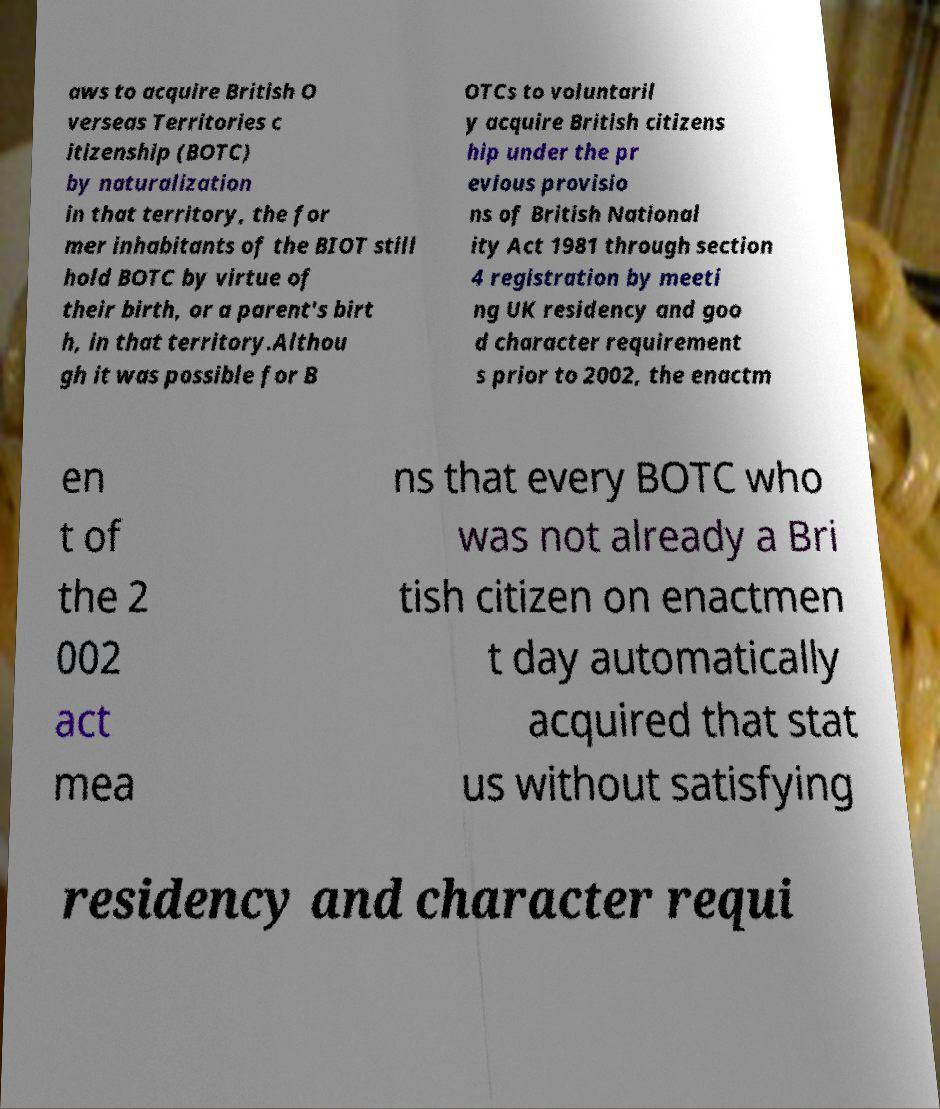I need the written content from this picture converted into text. Can you do that? aws to acquire British O verseas Territories c itizenship (BOTC) by naturalization in that territory, the for mer inhabitants of the BIOT still hold BOTC by virtue of their birth, or a parent's birt h, in that territory.Althou gh it was possible for B OTCs to voluntaril y acquire British citizens hip under the pr evious provisio ns of British National ity Act 1981 through section 4 registration by meeti ng UK residency and goo d character requirement s prior to 2002, the enactm en t of the 2 002 act mea ns that every BOTC who was not already a Bri tish citizen on enactmen t day automatically acquired that stat us without satisfying residency and character requi 